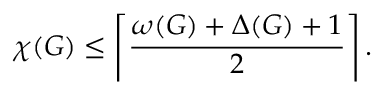<formula> <loc_0><loc_0><loc_500><loc_500>\chi ( G ) \leq \left \lceil { \frac { \omega ( G ) + \Delta ( G ) + 1 } { 2 } } \right \rceil .</formula> 